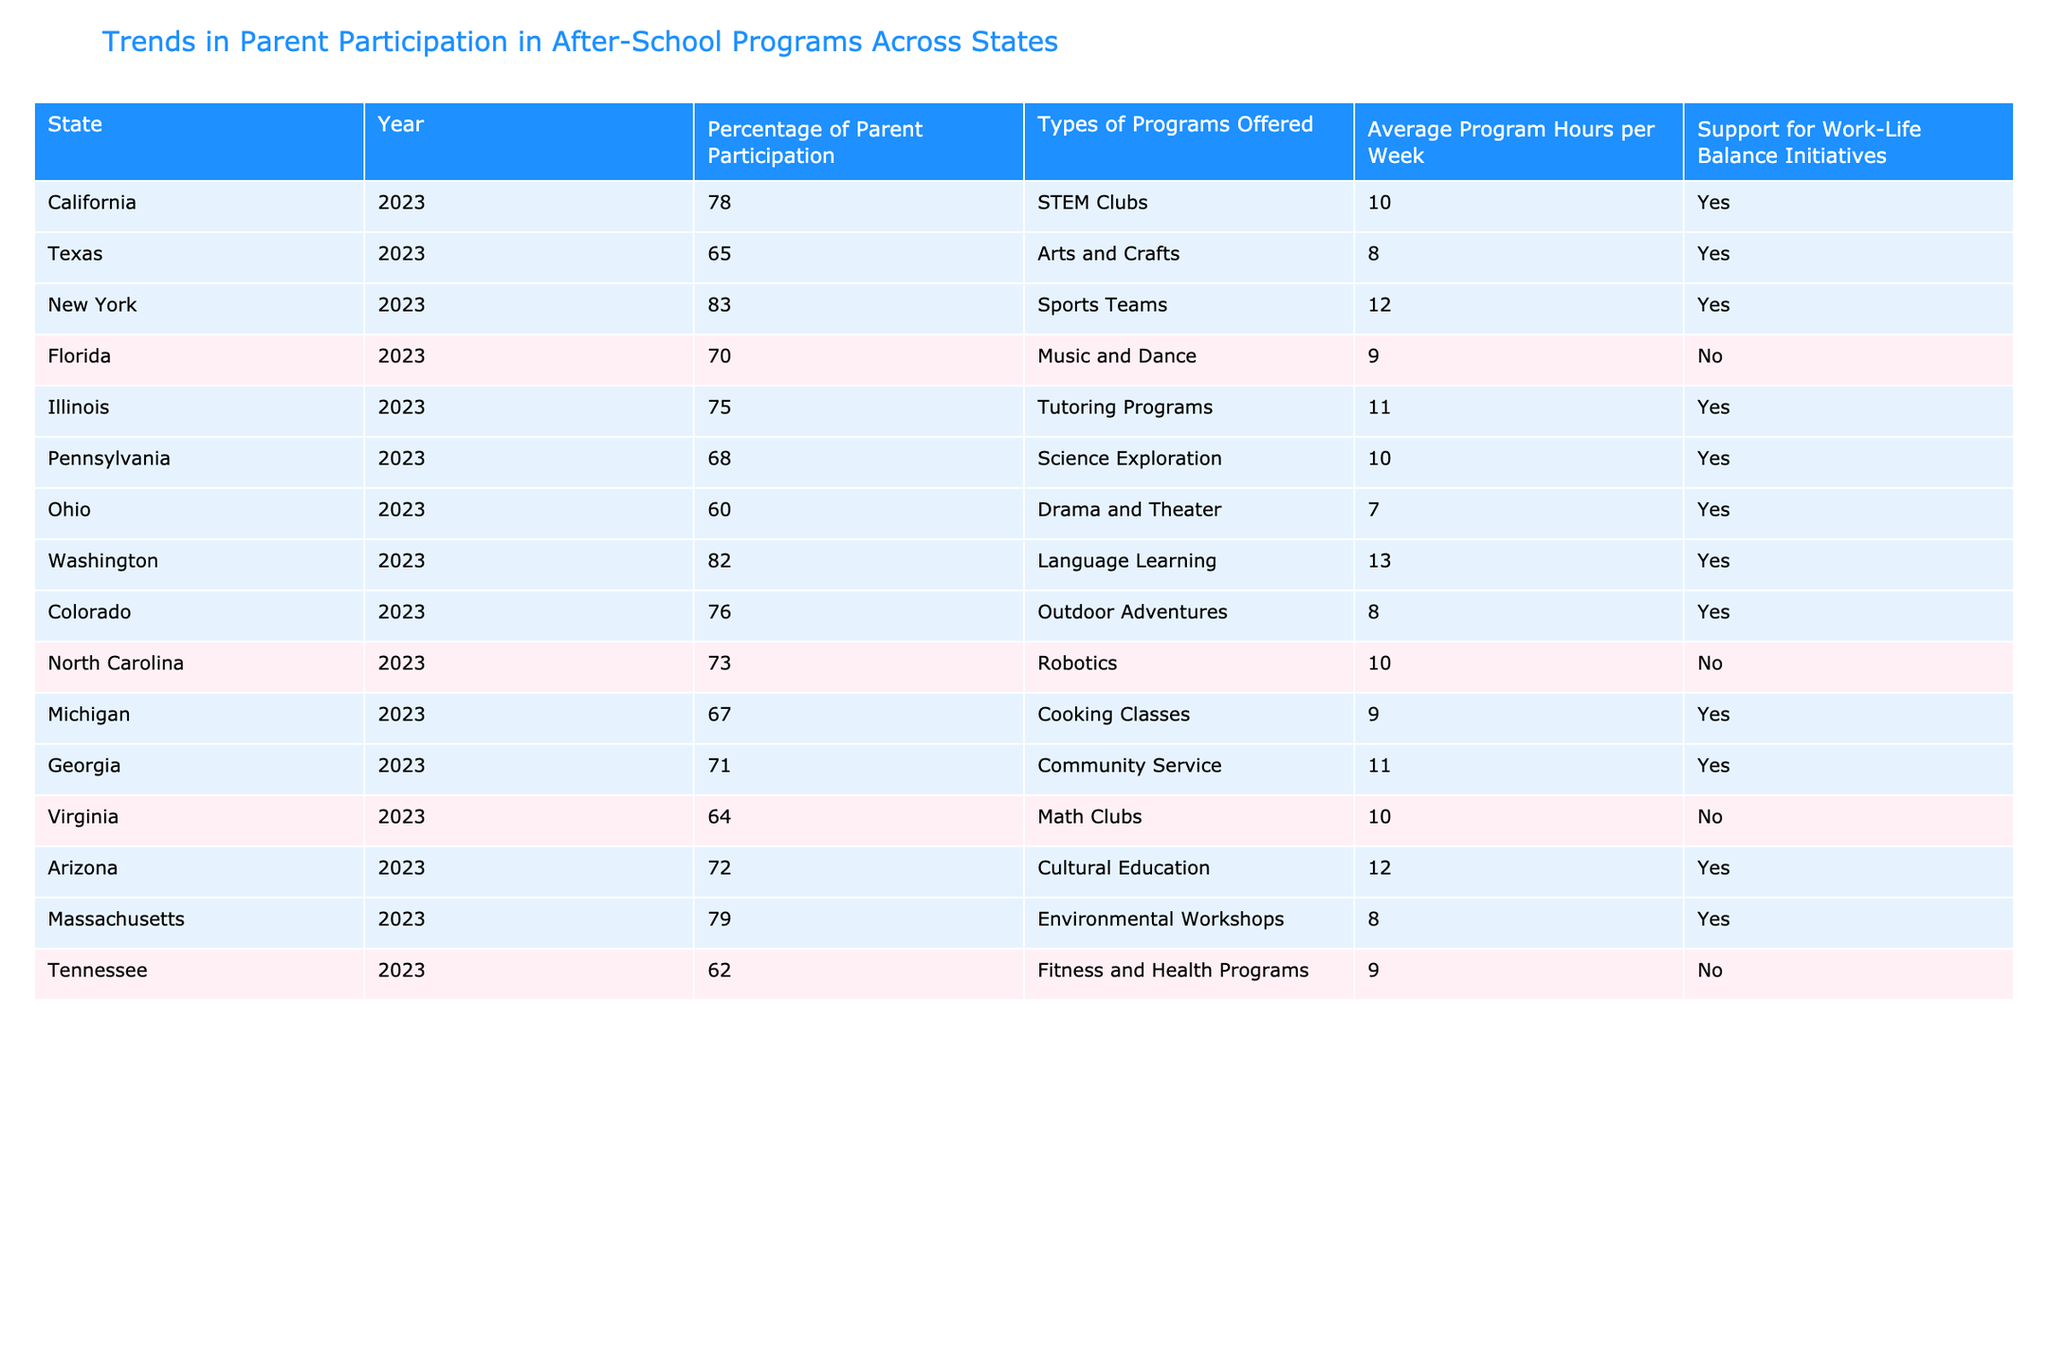What state has the highest percentage of parent participation in after-school programs? Looking at the table, New York shows a percentage of 83%, which is the highest among all listed states for 2023.
Answer: New York What is the average percentage of parent participation across all states listed? To find the average, sum the percentages: 78 + 65 + 83 + 70 + 75 + 68 + 60 + 82 + 76 + 73 + 67 + 71 + 64 + 72 + 79 + 62 = 1172. There are 16 states, so the average is 1172 / 16 = 73%.
Answer: 73% Which two states have the lowest support for work-life balance initiatives? The states with 'No' support for work-life balance initiatives are Florida and Virginia.
Answer: Florida and Virginia Does California offer programs that support work-life balance initiatives? Yes, California has 'Yes' listed under support for work-life balance initiatives in the table.
Answer: Yes If you compare the average program hours per week between states with and without work-life balance support, which is higher? Calculate the average for states with support: (10 + 8 + 12 + 11 + 10 + 8 + 11 + 10 + 12 + 9) = 102 hours; average = 102 / 10 = 10.2 hours. For states without support: (9 + 10 + 9) = 28 hours; average = 28 / 3 = 9.33 hours. The average is higher for states with support.
Answer: States with support have higher average hours Which type of program is most common among states with support for work-life balance initiatives? By reviewing the program types, we see that there are varied offerings including STEM Clubs, Sports Teams, and Environmental Workshops, but no commonality stated directly, making this difficult to determine without more context.
Answer: Not determinate without additional context What is the total number of states that offered Cultural Education as a program? Cultural Education is offered only by Arizona, making it a single instance in the data.
Answer: One state 